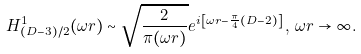Convert formula to latex. <formula><loc_0><loc_0><loc_500><loc_500>H ^ { 1 } _ { ( D - 3 ) / 2 } ( \omega r ) \sim \sqrt { \frac { 2 } { \pi ( \omega r ) } } e ^ { i \left [ \omega r - \frac { \pi } { 4 } ( D - 2 ) \right ] } \, , \, \omega r \rightarrow \infty .</formula> 